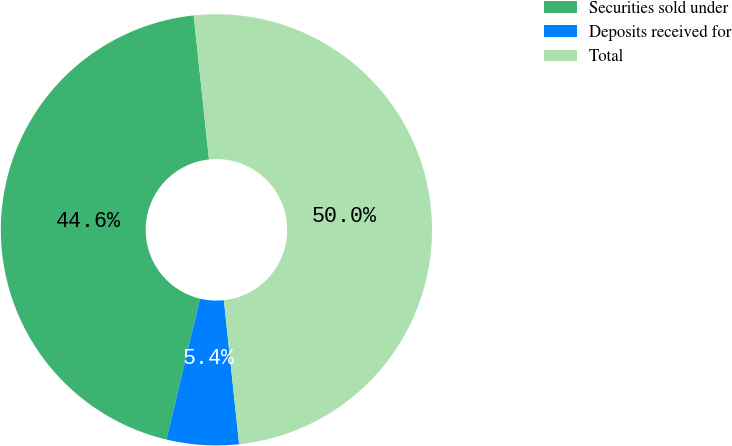Convert chart. <chart><loc_0><loc_0><loc_500><loc_500><pie_chart><fcel>Securities sold under<fcel>Deposits received for<fcel>Total<nl><fcel>44.6%<fcel>5.4%<fcel>50.0%<nl></chart> 